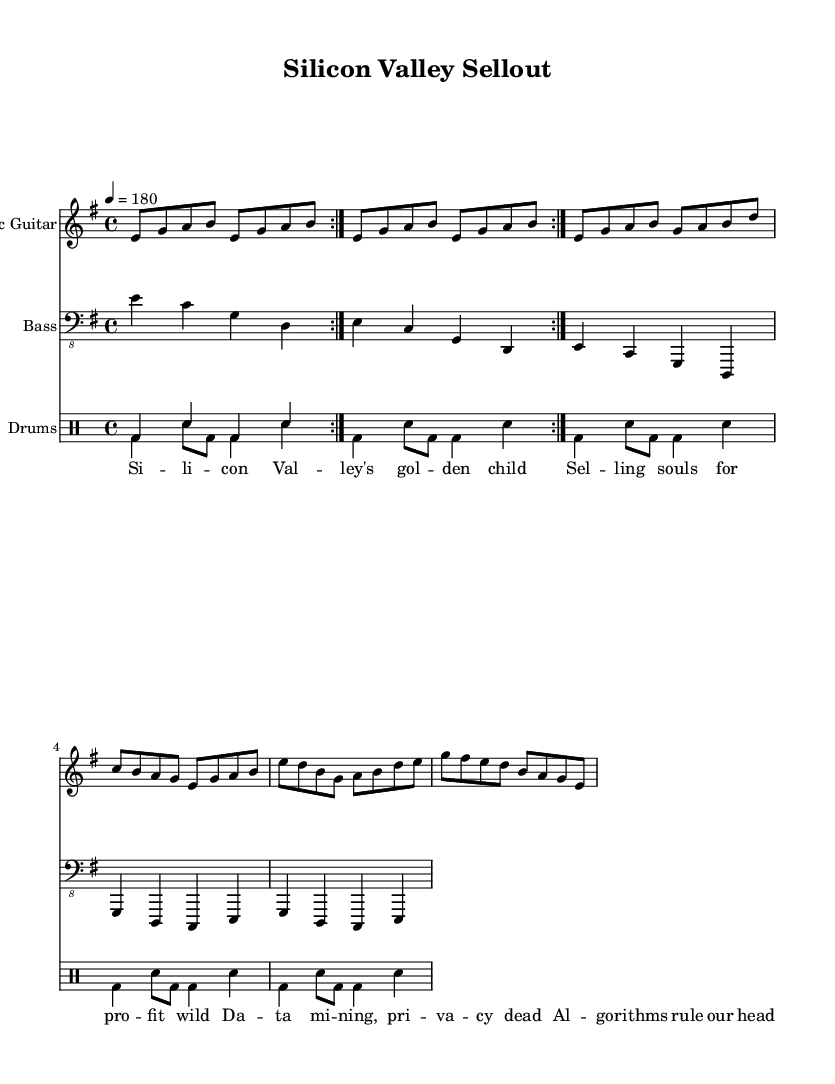What is the key signature of this music? The key signature is E minor, which has one sharp (F#). You can see this indicated at the beginning of the sheet music right after the clef.
Answer: E minor What is the time signature of this music? The time signature is 4/4, represented at the beginning of the score, indicating that there are four beats in each measure with a quarter note receiving one beat.
Answer: 4/4 What is the tempo marking in the sheet music? The tempo marking is marked as 4 = 180, which indicates that the quarter note should be played at 180 beats per minute. This is usually found in the header section of the score.
Answer: 180 What genre does this piece represent based on the lyrics? The piece is classified as Punk due to its themes of rebellion, critiques against corporate monopolies, and the style of music indicated by the title and lyrics. Punk music often addresses social issues and challenges authority.
Answer: Punk How many distinct instruments are represented in the score? The score features three distinct instruments: Electric Guitar, Bass, and Drums. Each is indicated by a separate staff in the score. This can be determined by looking at the instrument names found at the beginning of each staff.
Answer: 3 What is the primary theme of the lyrics? The lyrics primarily critique the excessive commercialization and ethical concerns surrounding the tech industry, particularly focusing on the loss of privacy and data exploitation. This theme is evident in phrases that mention selling souls and algorithms.
Answer: Rebellious critique 